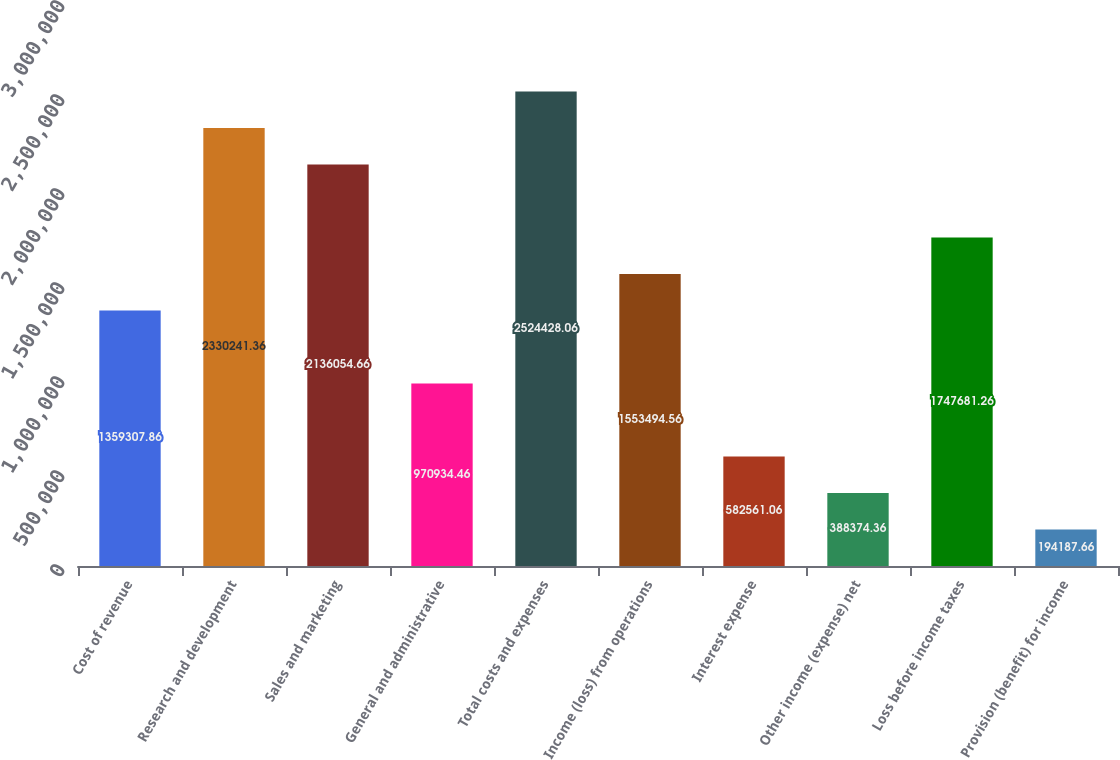<chart> <loc_0><loc_0><loc_500><loc_500><bar_chart><fcel>Cost of revenue<fcel>Research and development<fcel>Sales and marketing<fcel>General and administrative<fcel>Total costs and expenses<fcel>Income (loss) from operations<fcel>Interest expense<fcel>Other income (expense) net<fcel>Loss before income taxes<fcel>Provision (benefit) for income<nl><fcel>1.35931e+06<fcel>2.33024e+06<fcel>2.13605e+06<fcel>970934<fcel>2.52443e+06<fcel>1.55349e+06<fcel>582561<fcel>388374<fcel>1.74768e+06<fcel>194188<nl></chart> 